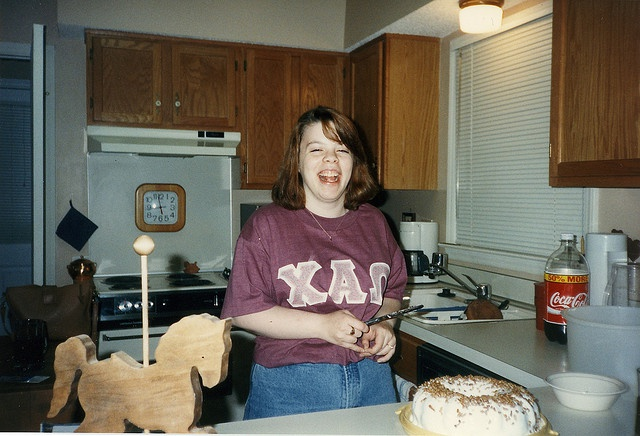Describe the objects in this image and their specific colors. I can see people in black, brown, gray, maroon, and purple tones, horse in black, tan, and gray tones, oven in black, gray, and darkgray tones, cake in black, beige, darkgray, tan, and gray tones, and bottle in black, gray, maroon, and darkgray tones in this image. 